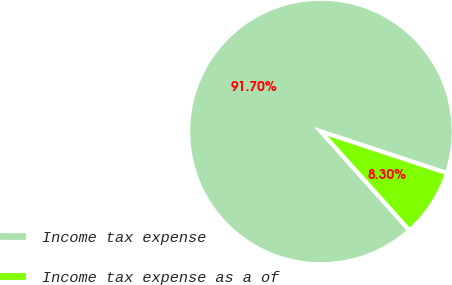<chart> <loc_0><loc_0><loc_500><loc_500><pie_chart><fcel>Income tax expense<fcel>Income tax expense as a of<nl><fcel>91.7%<fcel>8.3%<nl></chart> 